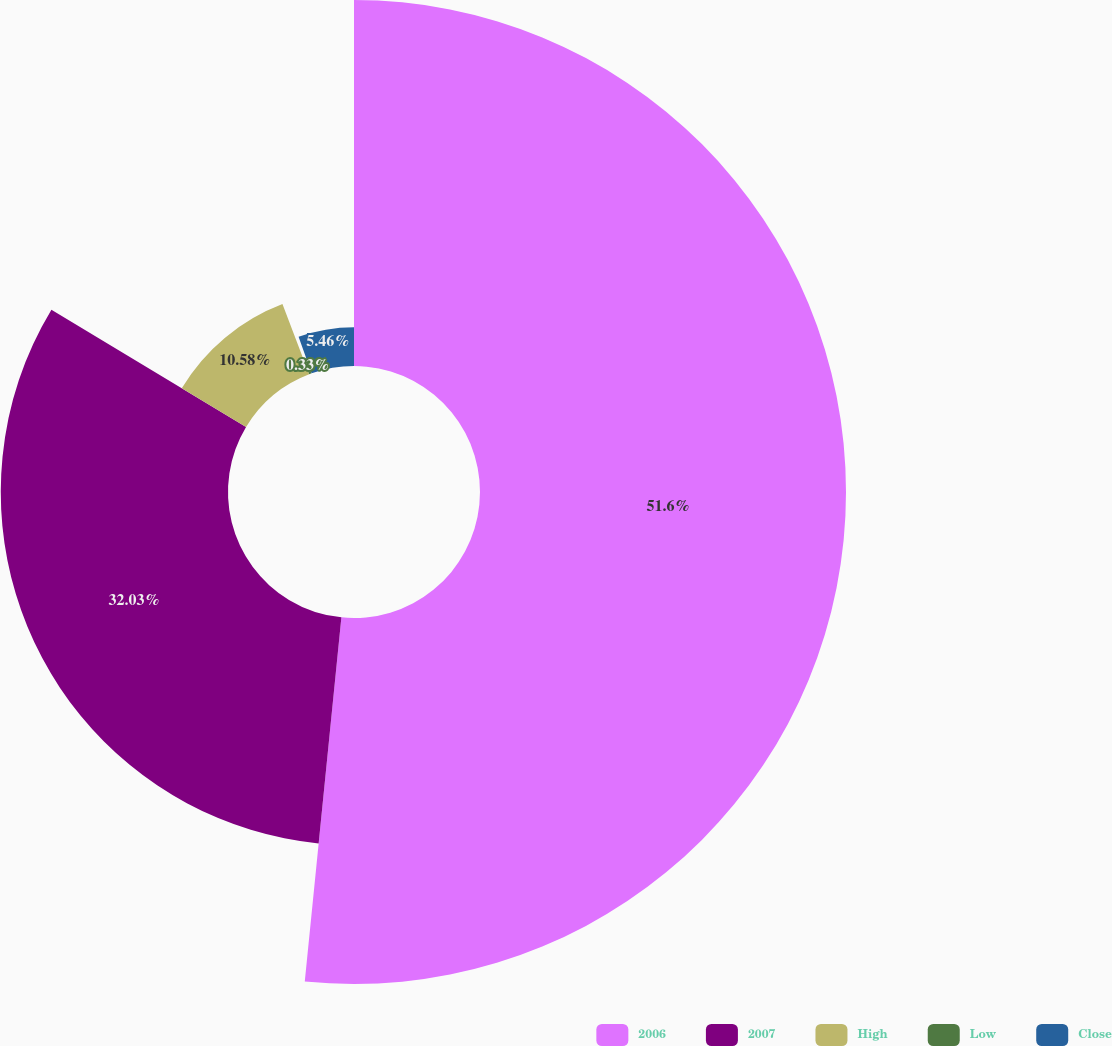Convert chart. <chart><loc_0><loc_0><loc_500><loc_500><pie_chart><fcel>2006<fcel>2007<fcel>High<fcel>Low<fcel>Close<nl><fcel>51.59%<fcel>32.03%<fcel>10.58%<fcel>0.33%<fcel>5.46%<nl></chart> 